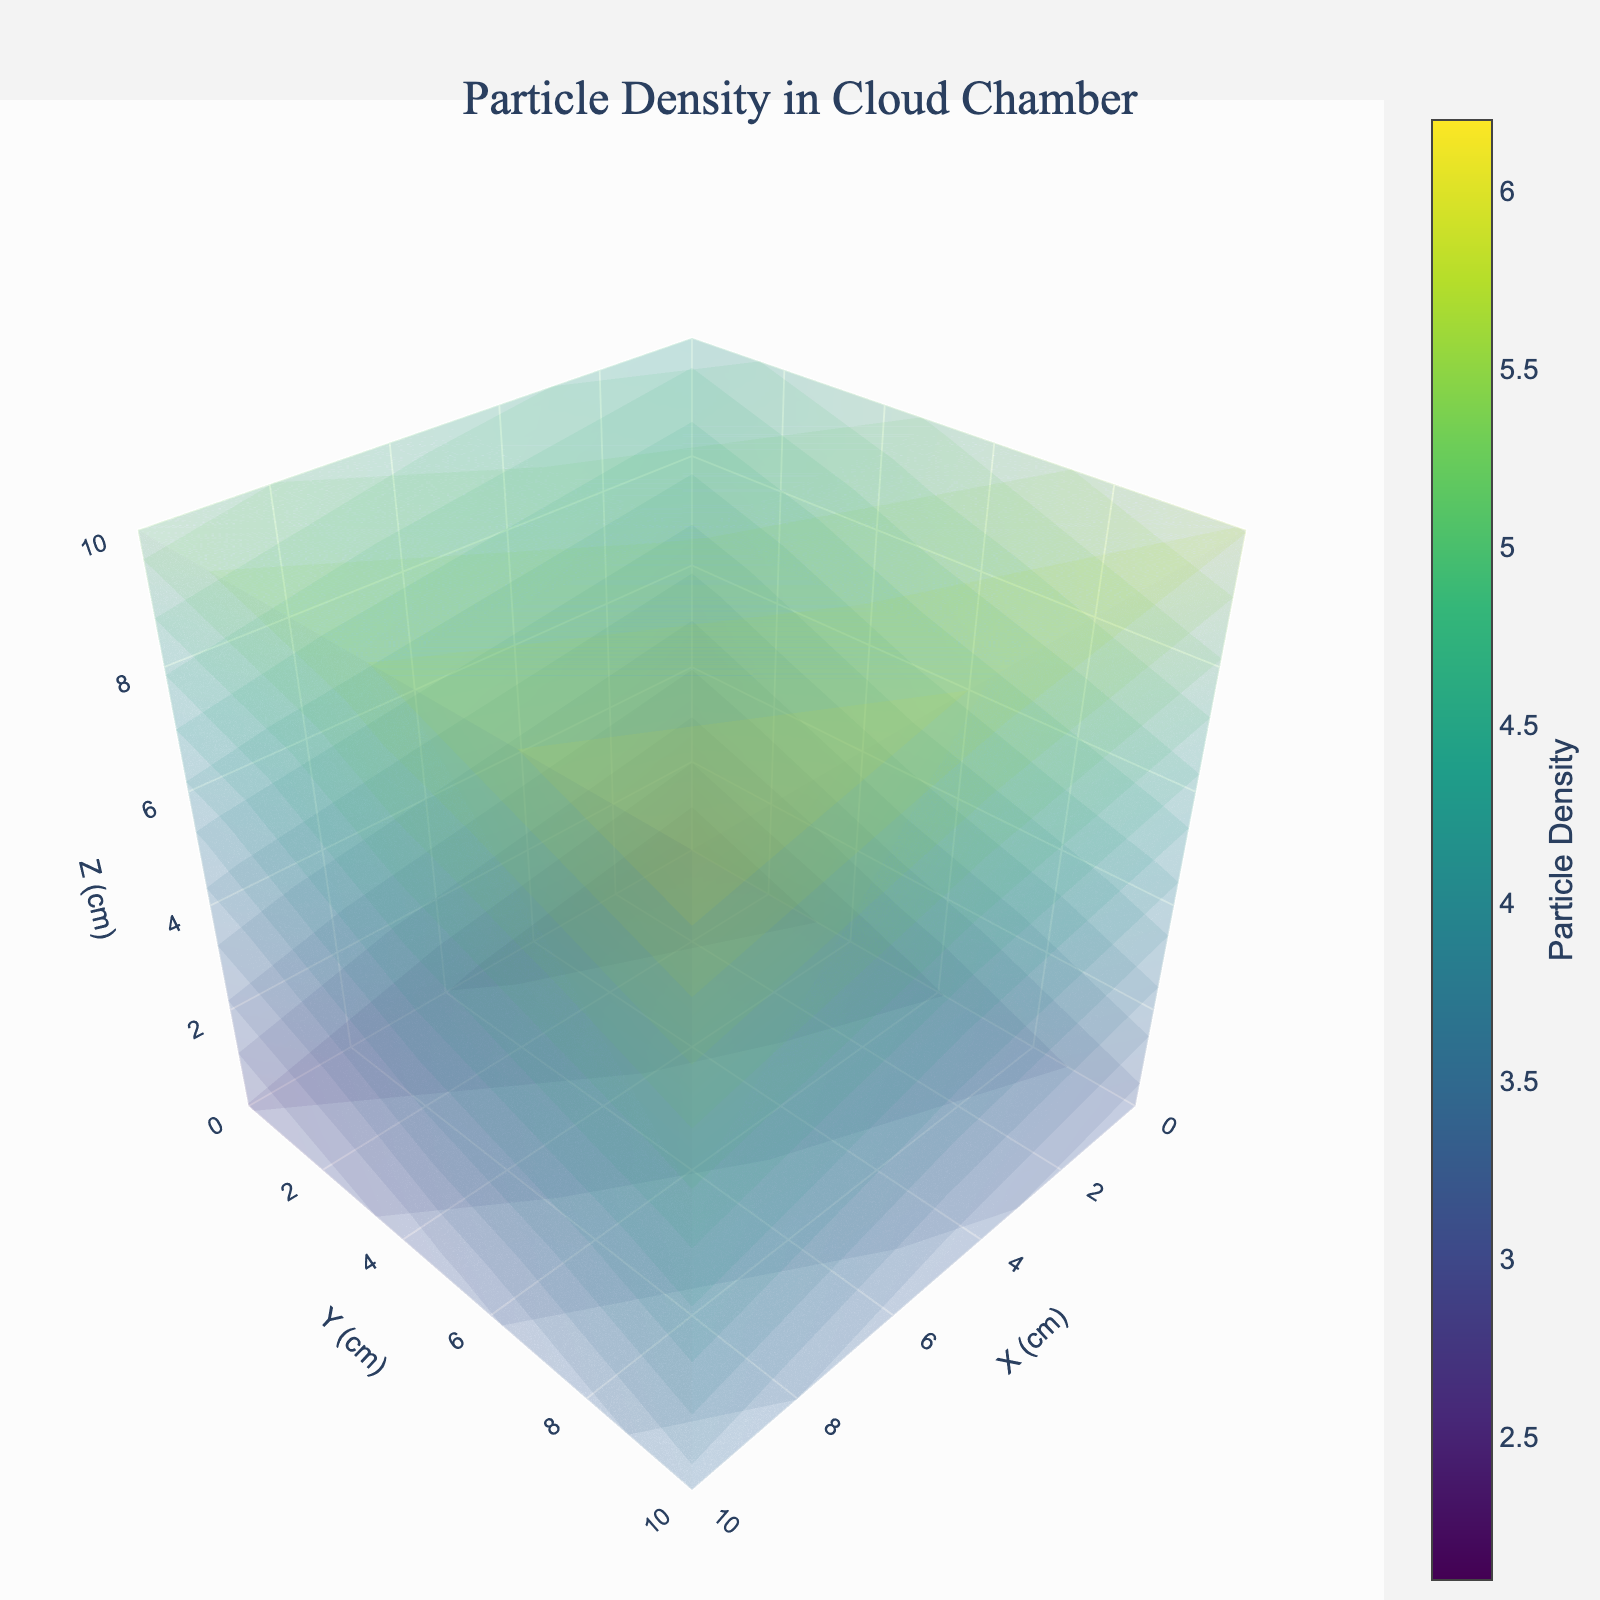what is the title of the plot? The title of the plot is often one of the most visually distinct elements at the top of the figure. It conveys the overall subject or dataset being presented.
Answer: Particle Density in Cloud Chamber what are the titles of the axes in the plot? Axis titles label the axes and describe what the dimensions represent. They are located next to each axis in the figure.
Answer: X (cm), Y (cm), Z (cm) what is the range of the x-axis in the figure? The range of an axis can be understood by looking at the minimum and maximum values indicated on the axis.
Answer: 0 to 10 how many surface layers are represented in the plot, and what do they represent? The surface layers represent different levels of particle densities in the cloud chamber. The figure uses visual elements like logarithmic coloring or layering to indicate this. Counting the layers visible or referring to the figure's contextual information (like a legend) would help determine this.
Answer: 17 layers which region (x, y, z) shows the maximum particle density? To find the region with the highest particle density, look for the area in the volume plot where the color intensity is highest, as indicated by the color scale.
Answer: (10, 10, 10) what is the particle density value at the point (5, 5, 5)? Locate the coordinates (5, 5, 5) on the plot, and find the corresponding particle density value using the color scale.
Answer: 4.1 compare the particle density at points (0, 0, 0) and (10, 10, 10). Which is higher? Identify the particle density values at the specified coordinates using the color scale and compare them to determine which is higher.
Answer: (10, 10, 10) is higher what is the average particle density along the z-axis at y=5 and x=5? Identify the particle density values at points (5, 5, 0), (5, 5, 5), and (5, 5, 10) and then calculate the average of these values. 
Particle density values: 2.7, 4.1, 5.4. 
Average = (2.7 + 4.1 + 5.4) / 3 = 4.07
Answer: 4.07 does the particle density tend to increase or decrease with higher z-values at y=10, x=0? Look at the particle density values at points (0, 10, 0), (0, 10, 5), and (0, 10, 10) and note the trend as z increases. 
Values: 3.0, 4.3, 5.7.
Trend: The values increase as z increases.
Answer: Increase how does the particle density at the center (5, 5, 5) compare to the average density at the edges (x=0, x=10, y=0, y=10)? Compute the particle densities at edges, then average them, and compare to the value at (5, 5, 5).
Edge densities: (2.1, 3.0, 2.6, 3.5, 3.9, 4.3, 4.8, 5.7, 5.2, 5.7)
Average edge density = (2.1 + 3.0 + 2.6 + 3.5 + 3.9 + 4.3 + 4.8 + 5.7 + 5.2 + 5.7) / 10 = 4.08
Compare to (5, 5, 5) density of 4.1. 
The particle density at the center is slightly less than the average density at the edges.
Answer: Center (5, 5, 5) is slightly less 